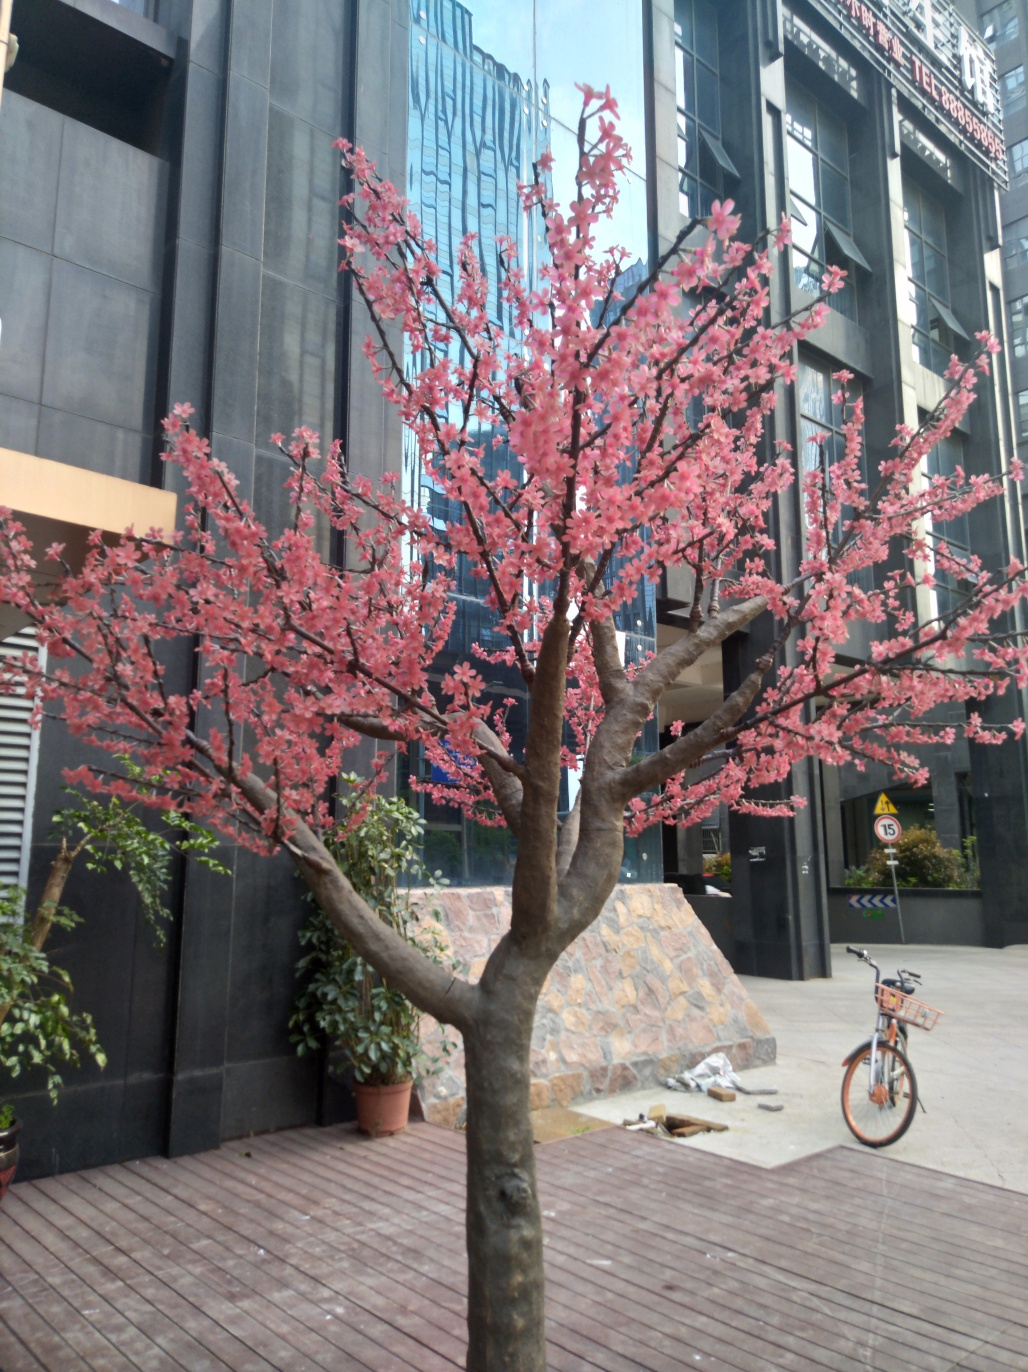Can you describe the urban environment where this tree is located? The tree is situated on a wooden deck amidst modern urban surroundings, with tall buildings featuring glass facades in the background. It provides a splash of natural beauty contrasting with the man-made structures around it. Does the presence of this tree suggest a particular care for green spaces in this urban setting? Yes, the careful placement of the tree along with potted plants indicates an effort to integrate greenery and enhance the aesthetics of public spaces, possibly to provide a pleasant environment for city dwellers and promote biodiversity. 